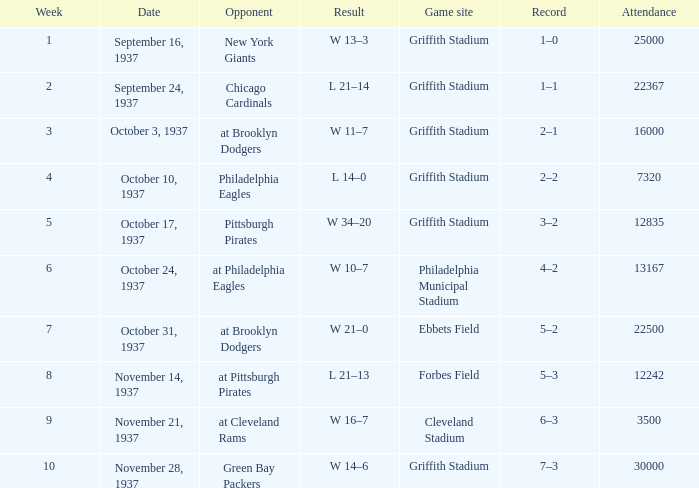On october 17, 1937, what was the maximum count of participants? 12835.0. 